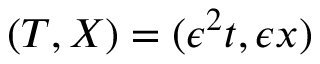Convert formula to latex. <formula><loc_0><loc_0><loc_500><loc_500>\begin{array} { r } { ( T , X ) = ( \epsilon ^ { 2 } t , \epsilon x ) } \end{array}</formula> 